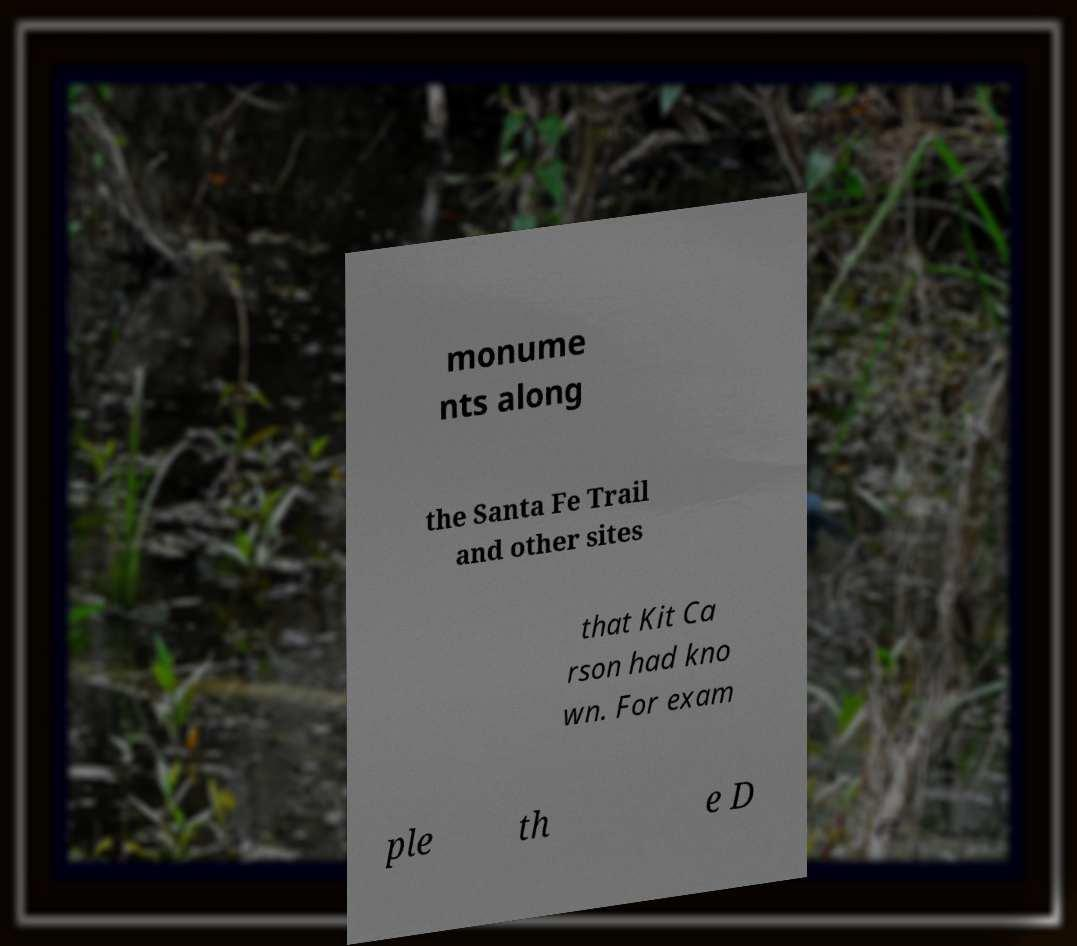Can you read and provide the text displayed in the image?This photo seems to have some interesting text. Can you extract and type it out for me? monume nts along the Santa Fe Trail and other sites that Kit Ca rson had kno wn. For exam ple th e D 